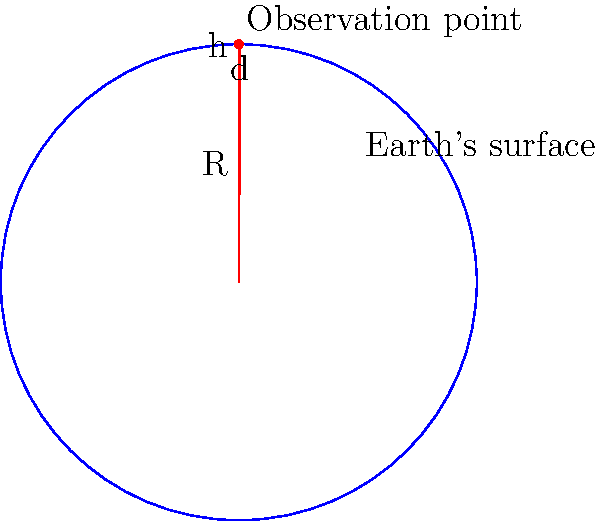Imagine you're standing on a cliff overlooking the ocean. Without using any electronic devices, how would you estimate the distance to the horizon? Consider that you're 100 meters above sea level and the Earth's radius is approximately 6371 km. Using basic trigonometry and the Earth's curvature, calculate the approximate distance to the horizon in kilometers. Let's approach this step-by-step using basic trigonometry:

1) First, let's consider the triangle formed by:
   - The center of the Earth
   - Your position on the cliff
   - The point on the horizon

2) This forms a right-angled triangle, where:
   - The hypotenuse is $R + h$, where $R$ is Earth's radius and $h$ is your height above sea level
   - One side is $R$
   - The other side is the distance to the horizon, let's call it $d$

3) Using the Pythagorean theorem:

   $$(R + h)^2 = R^2 + d^2$$

4) Expand this:

   $$R^2 + 2Rh + h^2 = R^2 + d^2$$

5) Simplify:

   $$2Rh + h^2 = d^2$$

6) Solve for $d$:

   $$d = \sqrt{2Rh + h^2}$$

7) Now, let's plug in our values:
   $R = 6371$ km
   $h = 100$ m = $0.1$ km

8) Calculate:

   $$d = \sqrt{2 * 6371 * 0.1 + 0.1^2}$$
   $$d = \sqrt{1274.2 + 0.01}$$
   $$d \approx 35.7$$ km

Therefore, the distance to the horizon is approximately 35.7 km.
Answer: $35.7$ km 